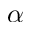Convert formula to latex. <formula><loc_0><loc_0><loc_500><loc_500>\alpha</formula> 